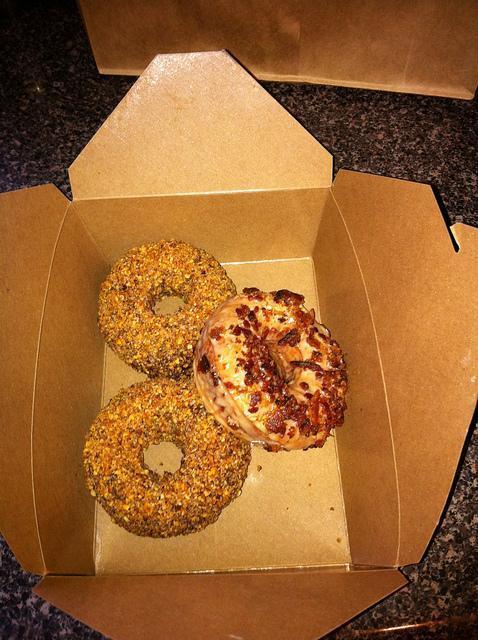How many doughnuts in the box?
Give a very brief answer. 3. How many donuts are visible?
Give a very brief answer. 3. 